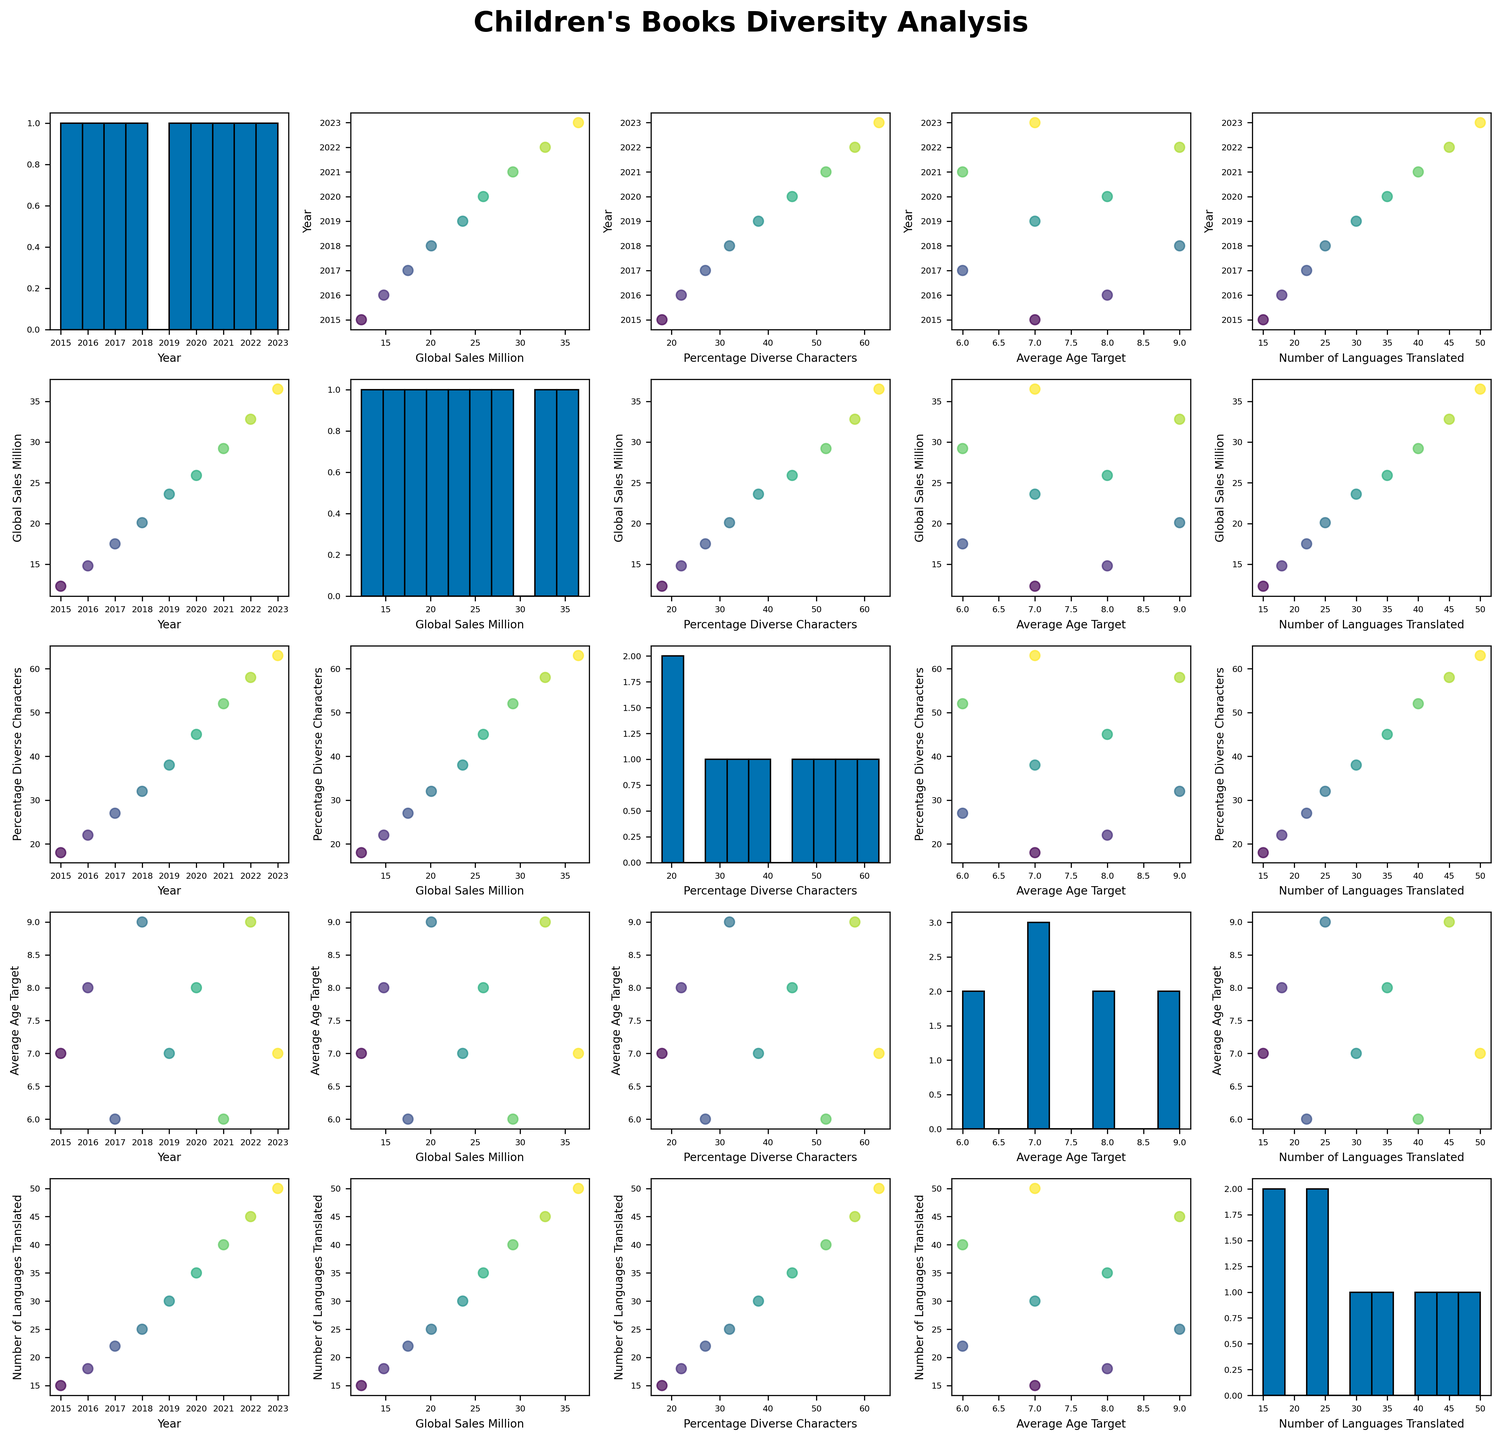What is the title of the figure? The title of the figure is located at the top center and is clearly displayed in bold.
Answer: Children's Books Diversity Analysis Which year has the highest global sales? By looking at the scatterplot with 'Year' on the x-axis and 'Global_Sales_Million' on the y-axis, find the highest point on the y-axis and check the corresponding year on the x-axis.
Answer: 2023 What’s the range of "Percentage of Diverse Characters" values depicted in the histogram? Look for the histogram plot on the diagonal corresponding to the "Percentage of Diverse Characters." Identify the minimum and maximum values shown on the x-axis.
Answer: 18 - 63 How does the number of languages translated correlate with global sales over the years? Examine the scatterplots where “Global_Sales_Million” and “Number_of_Languages_Translated” intersect with other variables. Check the trend among data points, specifically their positioning on the scatterplot.
Answer: Positive correlation Between which two consecutive years did the "Percentage of Diverse Characters" experience the most substantial increase? Evaluate the scatterplot or data points where 'Year' is on the x-axis and 'Percentage_Diverse_Characters' is on the y-axis. Compare the slopes or spacing between consecutive points.
Answer: 2020 and 2021 What trend can you observe between “Average Age Target” and "Global Sales Million"? Look for the scatterplot plotting 'Average_Age_Target' against 'Global_Sales_Million' and identify whether there's an increasing or decreasing trend.
Answer: No clear trend Which year had the most translations into different languages? Identify the scatterplot with 'Year' on the x-axis and 'Number_of_Languages_Translated' on the y-axis. Spot the highest y-axis value and its corresponding x-axis (year).
Answer: 2023 What age target had the least increase in global sales? Look at the scatterplot of 'Average_Age_Target' against 'Global_Sales_Million' and compare changes for each 'Average_Age_Target' across different years.
Answer: 6 years Is there any identifiable pattern in percentages of diverse characters over the years? Check the scatterplot involving 'Percentage_Diverse_Characters' and 'Year' to identify any observable trend in the percentage changes over the period.
Answer: Increasing trend 